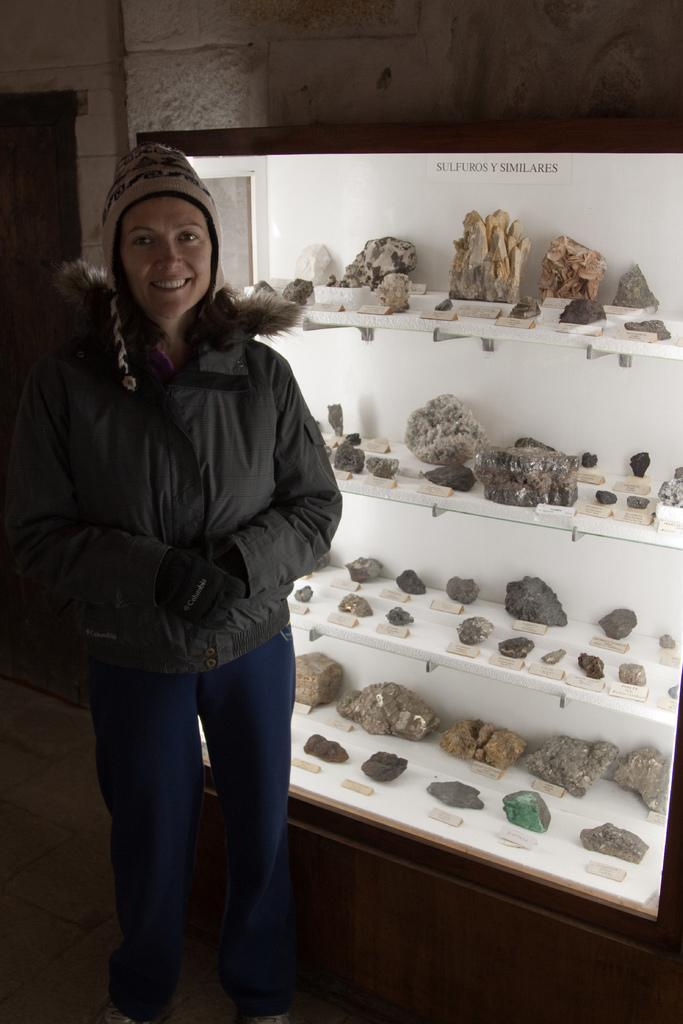What is the position of the woman in the image? The woman is standing on the left side of the picture. What is the woman wearing in the image? The woman is wearing a jacket in the image. What can be seen on the right side of the image? There are stones on the right side of the image. Where are the stones located in the image? The stones are in a closet in the image. What is the background of the image? There is a brick wall at the top of the image. What type of underwear is the woman wearing in the image? There is no information about the woman's underwear in the image, so it cannot be determined. 